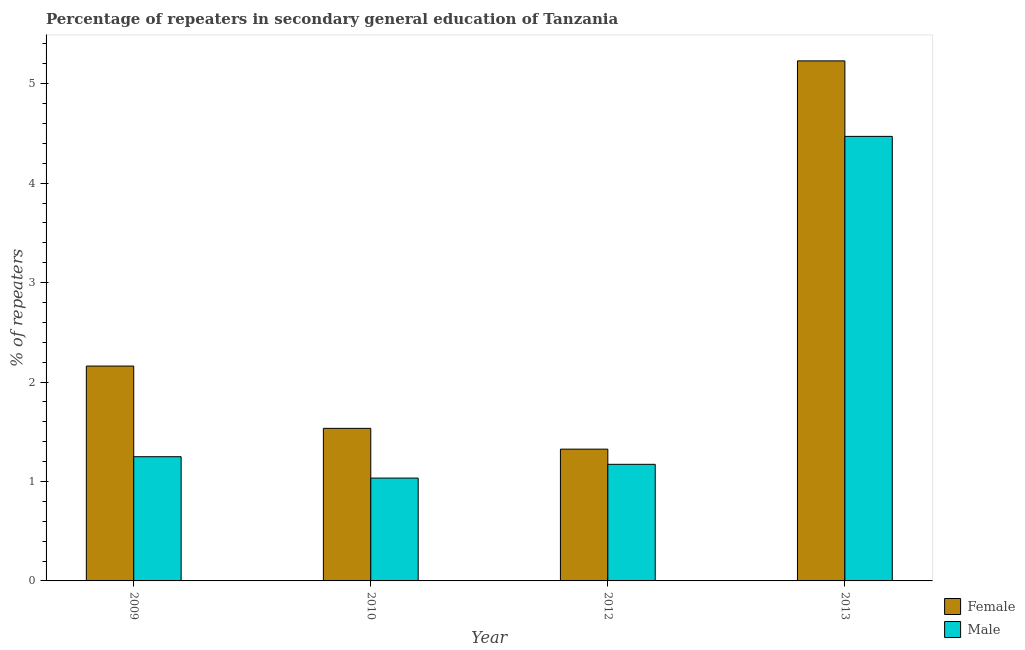Are the number of bars per tick equal to the number of legend labels?
Your answer should be compact. Yes. Are the number of bars on each tick of the X-axis equal?
Ensure brevity in your answer.  Yes. How many bars are there on the 4th tick from the left?
Provide a short and direct response. 2. How many bars are there on the 2nd tick from the right?
Make the answer very short. 2. In how many cases, is the number of bars for a given year not equal to the number of legend labels?
Ensure brevity in your answer.  0. What is the percentage of female repeaters in 2010?
Give a very brief answer. 1.53. Across all years, what is the maximum percentage of female repeaters?
Your response must be concise. 5.23. Across all years, what is the minimum percentage of female repeaters?
Offer a terse response. 1.33. In which year was the percentage of male repeaters maximum?
Your answer should be very brief. 2013. In which year was the percentage of female repeaters minimum?
Your answer should be very brief. 2012. What is the total percentage of female repeaters in the graph?
Ensure brevity in your answer.  10.25. What is the difference between the percentage of female repeaters in 2010 and that in 2013?
Keep it short and to the point. -3.7. What is the difference between the percentage of female repeaters in 2009 and the percentage of male repeaters in 2013?
Ensure brevity in your answer.  -3.07. What is the average percentage of female repeaters per year?
Offer a terse response. 2.56. In how many years, is the percentage of male repeaters greater than 0.6000000000000001 %?
Keep it short and to the point. 4. What is the ratio of the percentage of female repeaters in 2010 to that in 2013?
Give a very brief answer. 0.29. Is the percentage of male repeaters in 2009 less than that in 2013?
Make the answer very short. Yes. What is the difference between the highest and the second highest percentage of female repeaters?
Your answer should be very brief. 3.07. What is the difference between the highest and the lowest percentage of male repeaters?
Your answer should be compact. 3.44. What does the 2nd bar from the left in 2012 represents?
Offer a terse response. Male. How many bars are there?
Keep it short and to the point. 8. What is the difference between two consecutive major ticks on the Y-axis?
Your answer should be compact. 1. Does the graph contain grids?
Offer a very short reply. No. How are the legend labels stacked?
Your response must be concise. Vertical. What is the title of the graph?
Provide a succinct answer. Percentage of repeaters in secondary general education of Tanzania. What is the label or title of the Y-axis?
Offer a terse response. % of repeaters. What is the % of repeaters in Female in 2009?
Provide a succinct answer. 2.16. What is the % of repeaters of Male in 2009?
Provide a succinct answer. 1.25. What is the % of repeaters of Female in 2010?
Make the answer very short. 1.53. What is the % of repeaters in Male in 2010?
Provide a succinct answer. 1.03. What is the % of repeaters of Female in 2012?
Offer a terse response. 1.33. What is the % of repeaters of Male in 2012?
Offer a terse response. 1.17. What is the % of repeaters of Female in 2013?
Ensure brevity in your answer.  5.23. What is the % of repeaters of Male in 2013?
Your answer should be compact. 4.47. Across all years, what is the maximum % of repeaters in Female?
Give a very brief answer. 5.23. Across all years, what is the maximum % of repeaters of Male?
Offer a very short reply. 4.47. Across all years, what is the minimum % of repeaters of Female?
Your answer should be compact. 1.33. Across all years, what is the minimum % of repeaters of Male?
Your answer should be compact. 1.03. What is the total % of repeaters of Female in the graph?
Keep it short and to the point. 10.25. What is the total % of repeaters of Male in the graph?
Your answer should be compact. 7.93. What is the difference between the % of repeaters in Female in 2009 and that in 2010?
Provide a succinct answer. 0.63. What is the difference between the % of repeaters of Male in 2009 and that in 2010?
Provide a short and direct response. 0.21. What is the difference between the % of repeaters in Female in 2009 and that in 2012?
Your answer should be very brief. 0.84. What is the difference between the % of repeaters in Male in 2009 and that in 2012?
Ensure brevity in your answer.  0.08. What is the difference between the % of repeaters in Female in 2009 and that in 2013?
Your answer should be compact. -3.07. What is the difference between the % of repeaters in Male in 2009 and that in 2013?
Make the answer very short. -3.22. What is the difference between the % of repeaters of Female in 2010 and that in 2012?
Ensure brevity in your answer.  0.21. What is the difference between the % of repeaters of Male in 2010 and that in 2012?
Your answer should be very brief. -0.14. What is the difference between the % of repeaters of Female in 2010 and that in 2013?
Provide a succinct answer. -3.7. What is the difference between the % of repeaters of Male in 2010 and that in 2013?
Keep it short and to the point. -3.44. What is the difference between the % of repeaters of Female in 2012 and that in 2013?
Provide a succinct answer. -3.9. What is the difference between the % of repeaters of Male in 2012 and that in 2013?
Offer a terse response. -3.3. What is the difference between the % of repeaters of Female in 2009 and the % of repeaters of Male in 2010?
Provide a short and direct response. 1.13. What is the difference between the % of repeaters in Female in 2009 and the % of repeaters in Male in 2012?
Give a very brief answer. 0.99. What is the difference between the % of repeaters of Female in 2009 and the % of repeaters of Male in 2013?
Provide a succinct answer. -2.31. What is the difference between the % of repeaters of Female in 2010 and the % of repeaters of Male in 2012?
Offer a terse response. 0.36. What is the difference between the % of repeaters in Female in 2010 and the % of repeaters in Male in 2013?
Make the answer very short. -2.94. What is the difference between the % of repeaters in Female in 2012 and the % of repeaters in Male in 2013?
Your answer should be compact. -3.15. What is the average % of repeaters of Female per year?
Offer a terse response. 2.56. What is the average % of repeaters of Male per year?
Make the answer very short. 1.98. In the year 2009, what is the difference between the % of repeaters of Female and % of repeaters of Male?
Offer a very short reply. 0.91. In the year 2010, what is the difference between the % of repeaters in Female and % of repeaters in Male?
Offer a terse response. 0.5. In the year 2012, what is the difference between the % of repeaters of Female and % of repeaters of Male?
Your response must be concise. 0.15. In the year 2013, what is the difference between the % of repeaters of Female and % of repeaters of Male?
Your answer should be very brief. 0.76. What is the ratio of the % of repeaters in Female in 2009 to that in 2010?
Offer a very short reply. 1.41. What is the ratio of the % of repeaters in Male in 2009 to that in 2010?
Your answer should be very brief. 1.21. What is the ratio of the % of repeaters of Female in 2009 to that in 2012?
Ensure brevity in your answer.  1.63. What is the ratio of the % of repeaters of Male in 2009 to that in 2012?
Provide a short and direct response. 1.07. What is the ratio of the % of repeaters in Female in 2009 to that in 2013?
Give a very brief answer. 0.41. What is the ratio of the % of repeaters of Male in 2009 to that in 2013?
Keep it short and to the point. 0.28. What is the ratio of the % of repeaters in Female in 2010 to that in 2012?
Keep it short and to the point. 1.16. What is the ratio of the % of repeaters of Male in 2010 to that in 2012?
Give a very brief answer. 0.88. What is the ratio of the % of repeaters of Female in 2010 to that in 2013?
Ensure brevity in your answer.  0.29. What is the ratio of the % of repeaters of Male in 2010 to that in 2013?
Your response must be concise. 0.23. What is the ratio of the % of repeaters in Female in 2012 to that in 2013?
Offer a very short reply. 0.25. What is the ratio of the % of repeaters in Male in 2012 to that in 2013?
Give a very brief answer. 0.26. What is the difference between the highest and the second highest % of repeaters of Female?
Offer a very short reply. 3.07. What is the difference between the highest and the second highest % of repeaters of Male?
Offer a terse response. 3.22. What is the difference between the highest and the lowest % of repeaters of Female?
Offer a very short reply. 3.9. What is the difference between the highest and the lowest % of repeaters of Male?
Your response must be concise. 3.44. 